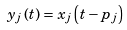Convert formula to latex. <formula><loc_0><loc_0><loc_500><loc_500>y _ { j } \left ( t \right ) = x _ { j } \left ( t - p _ { j } \right )</formula> 